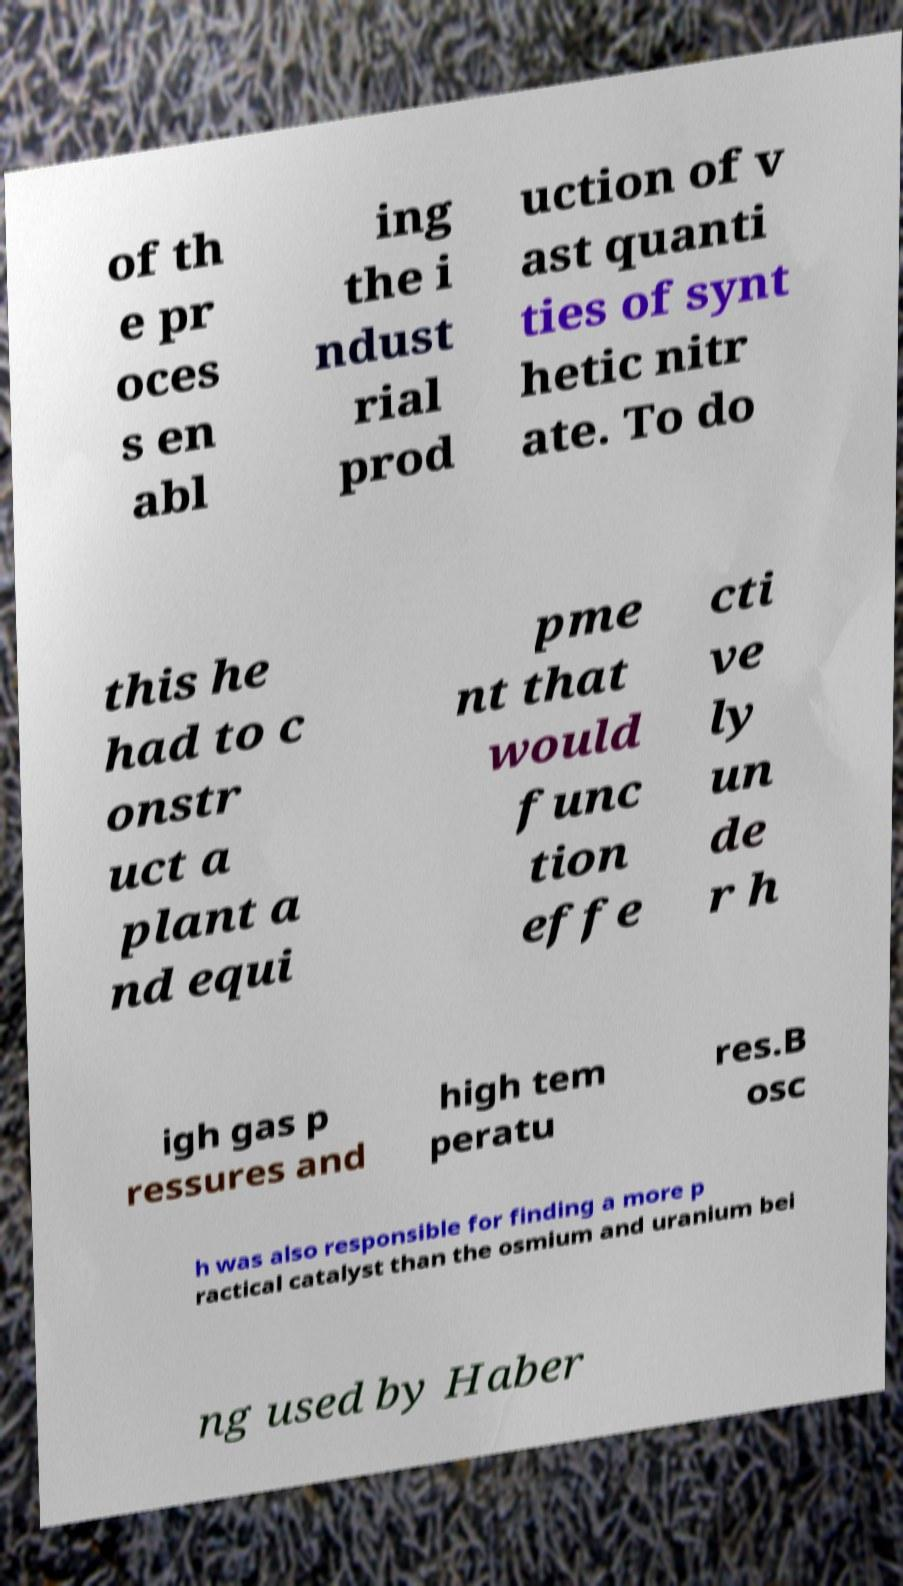Can you read and provide the text displayed in the image?This photo seems to have some interesting text. Can you extract and type it out for me? of th e pr oces s en abl ing the i ndust rial prod uction of v ast quanti ties of synt hetic nitr ate. To do this he had to c onstr uct a plant a nd equi pme nt that would func tion effe cti ve ly un de r h igh gas p ressures and high tem peratu res.B osc h was also responsible for finding a more p ractical catalyst than the osmium and uranium bei ng used by Haber 